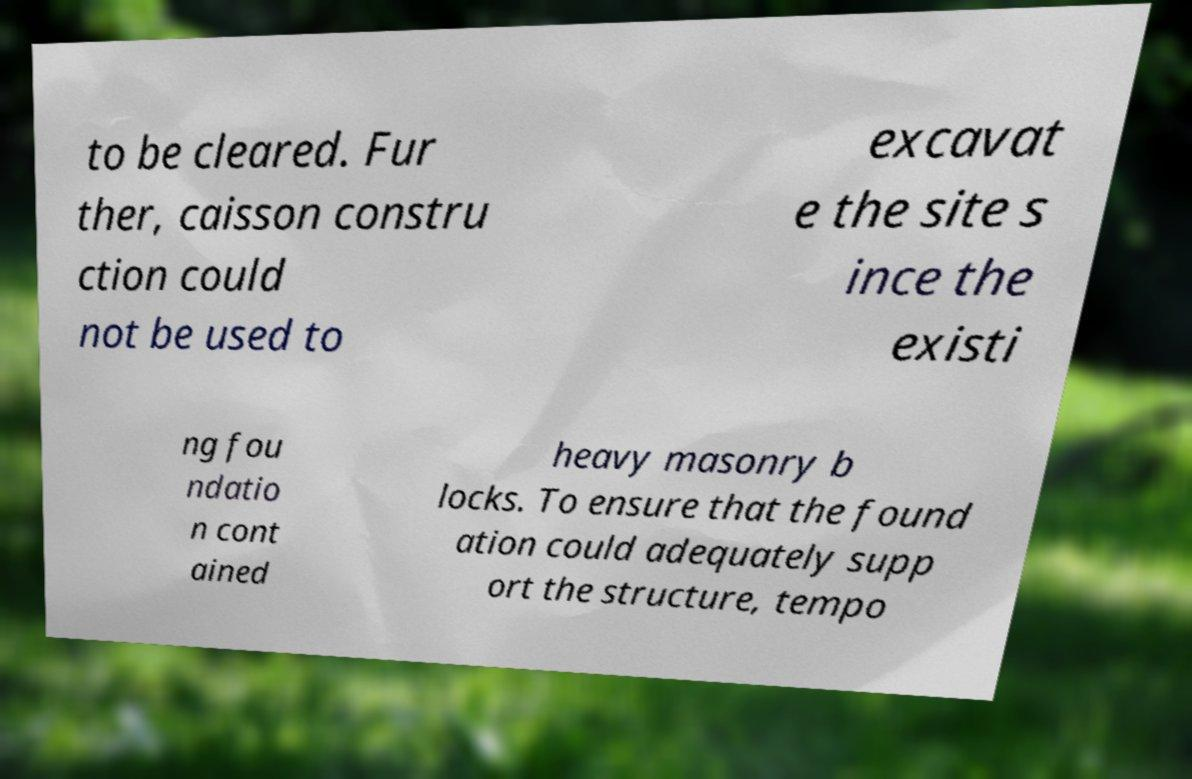There's text embedded in this image that I need extracted. Can you transcribe it verbatim? to be cleared. Fur ther, caisson constru ction could not be used to excavat e the site s ince the existi ng fou ndatio n cont ained heavy masonry b locks. To ensure that the found ation could adequately supp ort the structure, tempo 